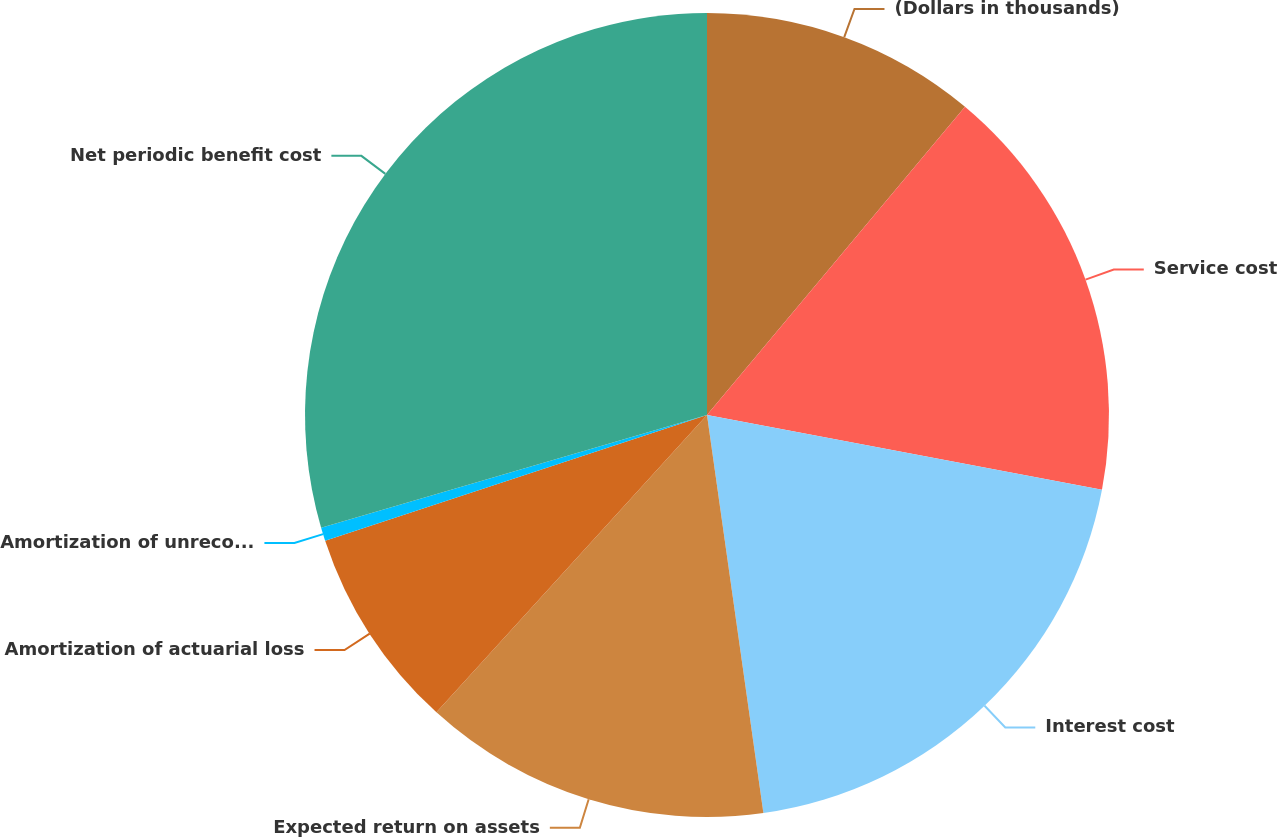Convert chart. <chart><loc_0><loc_0><loc_500><loc_500><pie_chart><fcel>(Dollars in thousands)<fcel>Service cost<fcel>Interest cost<fcel>Expected return on assets<fcel>Amortization of actuarial loss<fcel>Amortization of unrecognized<fcel>Net periodic benefit cost<nl><fcel>11.09%<fcel>16.89%<fcel>19.78%<fcel>13.99%<fcel>8.19%<fcel>0.54%<fcel>29.52%<nl></chart> 